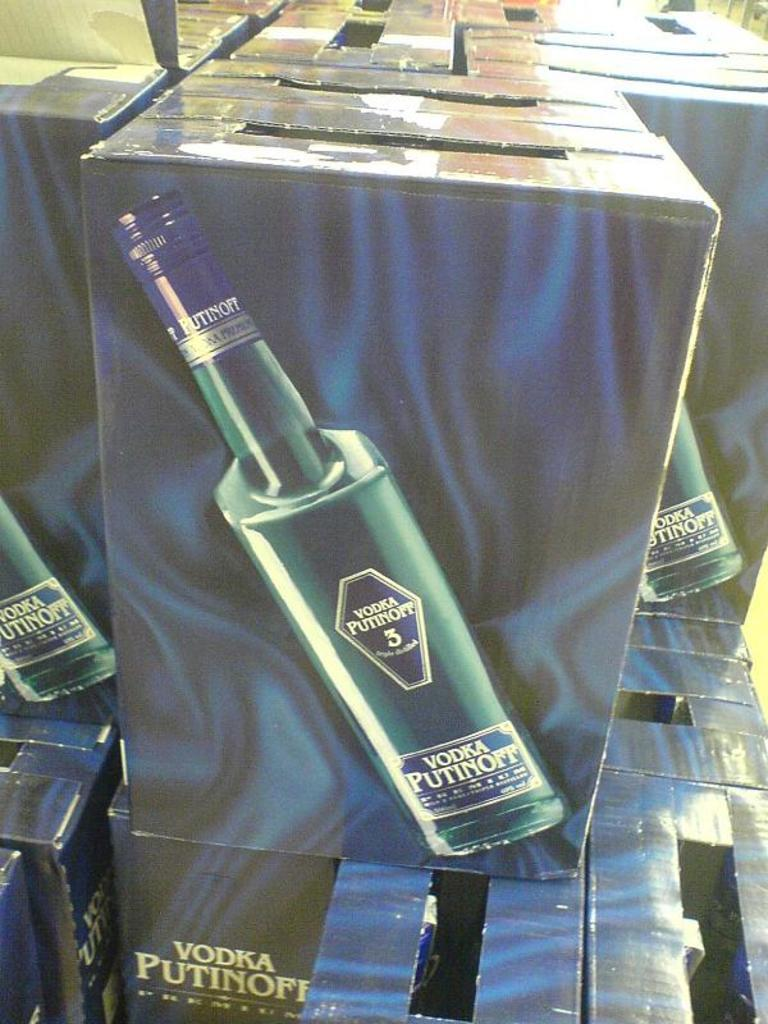<image>
Summarize the visual content of the image. a box with a picture of vodka putinoff on it 